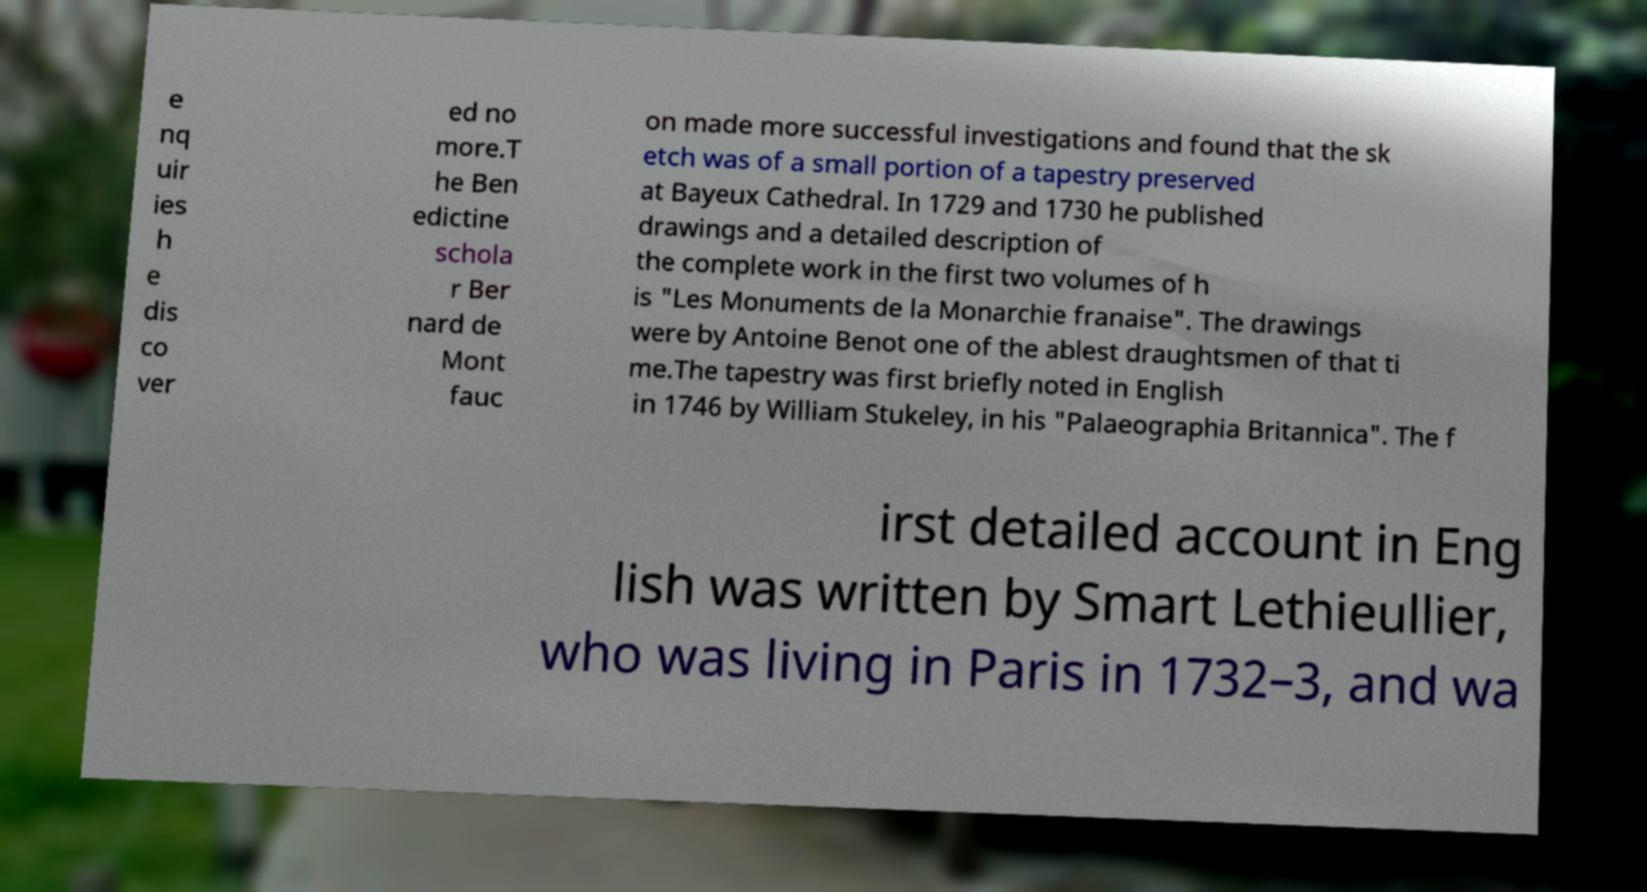Can you accurately transcribe the text from the provided image for me? e nq uir ies h e dis co ver ed no more.T he Ben edictine schola r Ber nard de Mont fauc on made more successful investigations and found that the sk etch was of a small portion of a tapestry preserved at Bayeux Cathedral. In 1729 and 1730 he published drawings and a detailed description of the complete work in the first two volumes of h is "Les Monuments de la Monarchie franaise". The drawings were by Antoine Benot one of the ablest draughtsmen of that ti me.The tapestry was first briefly noted in English in 1746 by William Stukeley, in his "Palaeographia Britannica". The f irst detailed account in Eng lish was written by Smart Lethieullier, who was living in Paris in 1732–3, and wa 